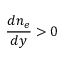Convert formula to latex. <formula><loc_0><loc_0><loc_500><loc_500>\frac { d n _ { e } } { d y } > 0</formula> 